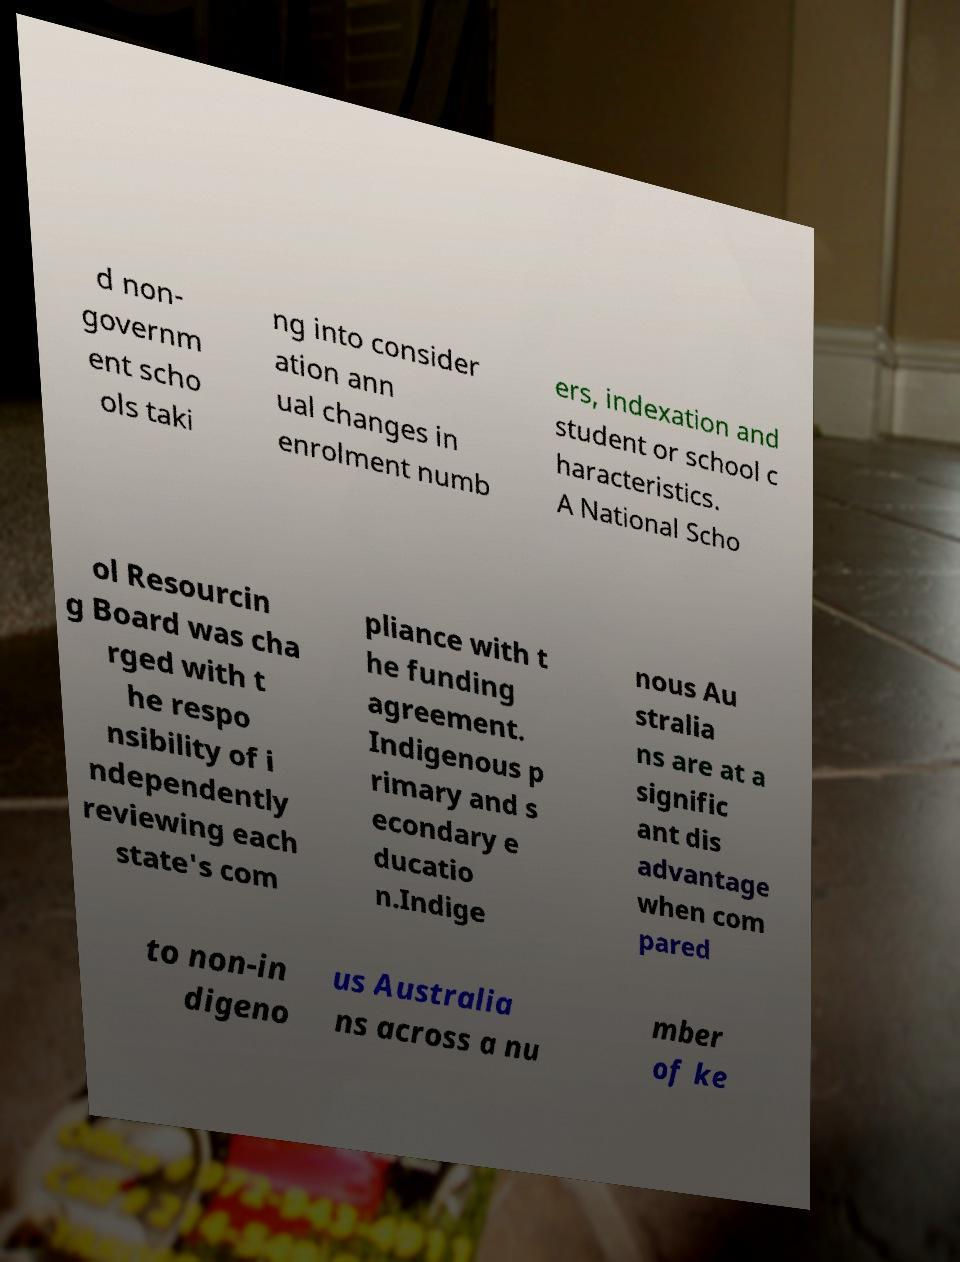Could you assist in decoding the text presented in this image and type it out clearly? d non- governm ent scho ols taki ng into consider ation ann ual changes in enrolment numb ers, indexation and student or school c haracteristics. A National Scho ol Resourcin g Board was cha rged with t he respo nsibility of i ndependently reviewing each state's com pliance with t he funding agreement. Indigenous p rimary and s econdary e ducatio n.Indige nous Au stralia ns are at a signific ant dis advantage when com pared to non-in digeno us Australia ns across a nu mber of ke 